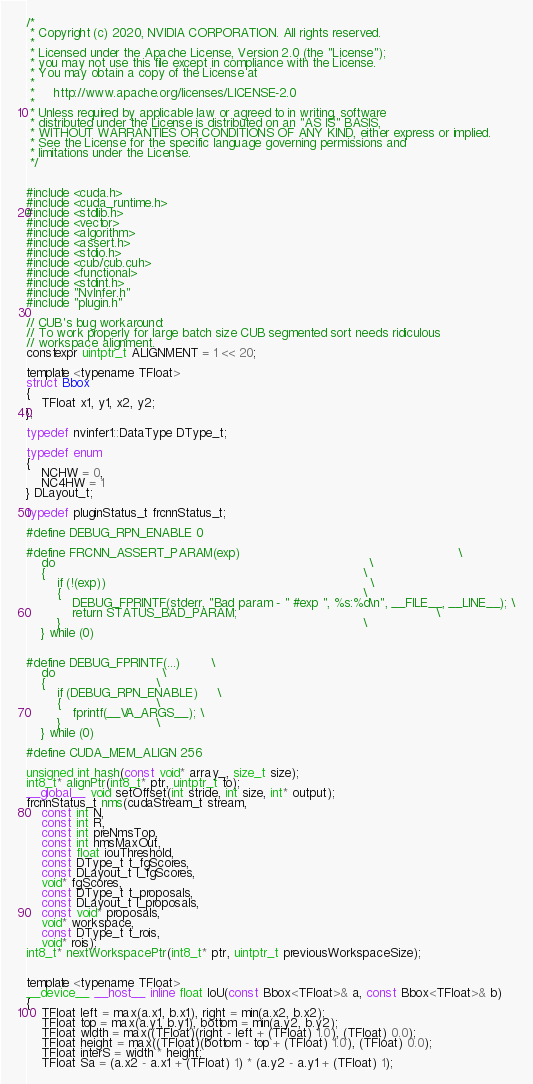<code> <loc_0><loc_0><loc_500><loc_500><_Cuda_>/*
 * Copyright (c) 2020, NVIDIA CORPORATION. All rights reserved.
 *
 * Licensed under the Apache License, Version 2.0 (the "License");
 * you may not use this file except in compliance with the License.
 * You may obtain a copy of the License at
 *
 *     http://www.apache.org/licenses/LICENSE-2.0
 *
 * Unless required by applicable law or agreed to in writing, software
 * distributed under the License is distributed on an "AS IS" BASIS,
 * WITHOUT WARRANTIES OR CONDITIONS OF ANY KIND, either express or implied.
 * See the License for the specific language governing permissions and
 * limitations under the License.
 */


#include <cuda.h>
#include <cuda_runtime.h>
#include <stdlib.h>
#include <vector>
#include <algorithm>
#include <assert.h>
#include <stdio.h>
#include <cub/cub.cuh>
#include <functional>
#include <stdint.h>
#include "NvInfer.h"
#include "plugin.h"

// CUB's bug workaround:
// To work properly for large batch size CUB segmented sort needs ridiculous
// workspace alignment.
constexpr uintptr_t ALIGNMENT = 1 << 20;

template <typename TFloat>
struct Bbox
{
    TFloat x1, y1, x2, y2;
};

typedef nvinfer1::DataType DType_t;

typedef enum
{
    NCHW = 0,
    NC4HW = 1
} DLayout_t;

typedef pluginStatus_t frcnnStatus_t;

#define DEBUG_RPN_ENABLE 0

#define FRCNN_ASSERT_PARAM(exp)                                                         \
    do                                                                                  \
    {                                                                                   \
        if (!(exp))                                                                     \
        {                                                                               \
            DEBUG_FPRINTF(stderr, "Bad param - " #exp ", %s:%d\n", __FILE__, __LINE__); \
            return STATUS_BAD_PARAM;                                                    \
        }                                                                               \
    } while (0)


#define DEBUG_FPRINTF(...)        \
    do                            \
    {                             \
        if (DEBUG_RPN_ENABLE)     \
        {                         \
            fprintf(__VA_ARGS__); \
        }                         \
    } while (0)

#define CUDA_MEM_ALIGN 256

unsigned int hash(const void* array_, size_t size);
int8_t* alignPtr(int8_t* ptr, uintptr_t to);
__global__ void setOffset(int stride, int size, int* output);
frcnnStatus_t nms(cudaStream_t stream,
    const int N,
    const int R,
    const int preNmsTop,
    const int nmsMaxOut,
    const float iouThreshold,
    const DType_t t_fgScores,
    const DLayout_t l_fgScores,
    void* fgScores,
    const DType_t t_proposals,
    const DLayout_t l_proposals,
    const void* proposals,
    void* workspace,
    const DType_t t_rois,
    void* rois);
int8_t* nextWorkspacePtr(int8_t* ptr, uintptr_t previousWorkspaceSize);


template <typename TFloat>
__device__ __host__ inline float IoU(const Bbox<TFloat>& a, const Bbox<TFloat>& b)
{
    TFloat left = max(a.x1, b.x1), right = min(a.x2, b.x2);
    TFloat top = max(a.y1, b.y1), bottom = min(a.y2, b.y2);
    TFloat width = max((TFloat)(right - left + (TFloat) 1.0), (TFloat) 0.0);
    TFloat height = max((TFloat)(bottom - top + (TFloat) 1.0), (TFloat) 0.0);
    TFloat interS = width * height;
    TFloat Sa = (a.x2 - a.x1 + (TFloat) 1) * (a.y2 - a.y1 + (TFloat) 1);</code> 